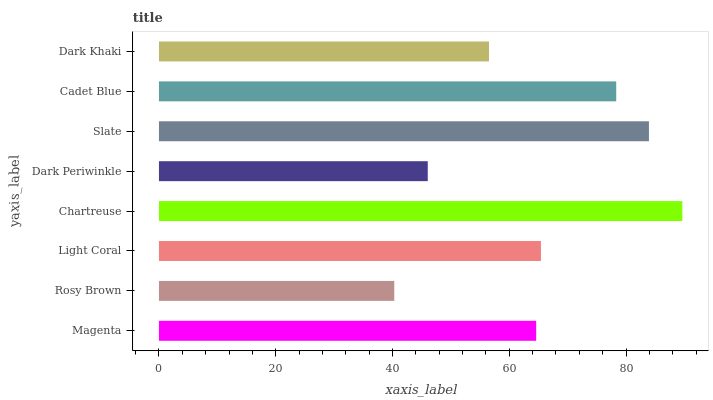Is Rosy Brown the minimum?
Answer yes or no. Yes. Is Chartreuse the maximum?
Answer yes or no. Yes. Is Light Coral the minimum?
Answer yes or no. No. Is Light Coral the maximum?
Answer yes or no. No. Is Light Coral greater than Rosy Brown?
Answer yes or no. Yes. Is Rosy Brown less than Light Coral?
Answer yes or no. Yes. Is Rosy Brown greater than Light Coral?
Answer yes or no. No. Is Light Coral less than Rosy Brown?
Answer yes or no. No. Is Light Coral the high median?
Answer yes or no. Yes. Is Magenta the low median?
Answer yes or no. Yes. Is Rosy Brown the high median?
Answer yes or no. No. Is Light Coral the low median?
Answer yes or no. No. 